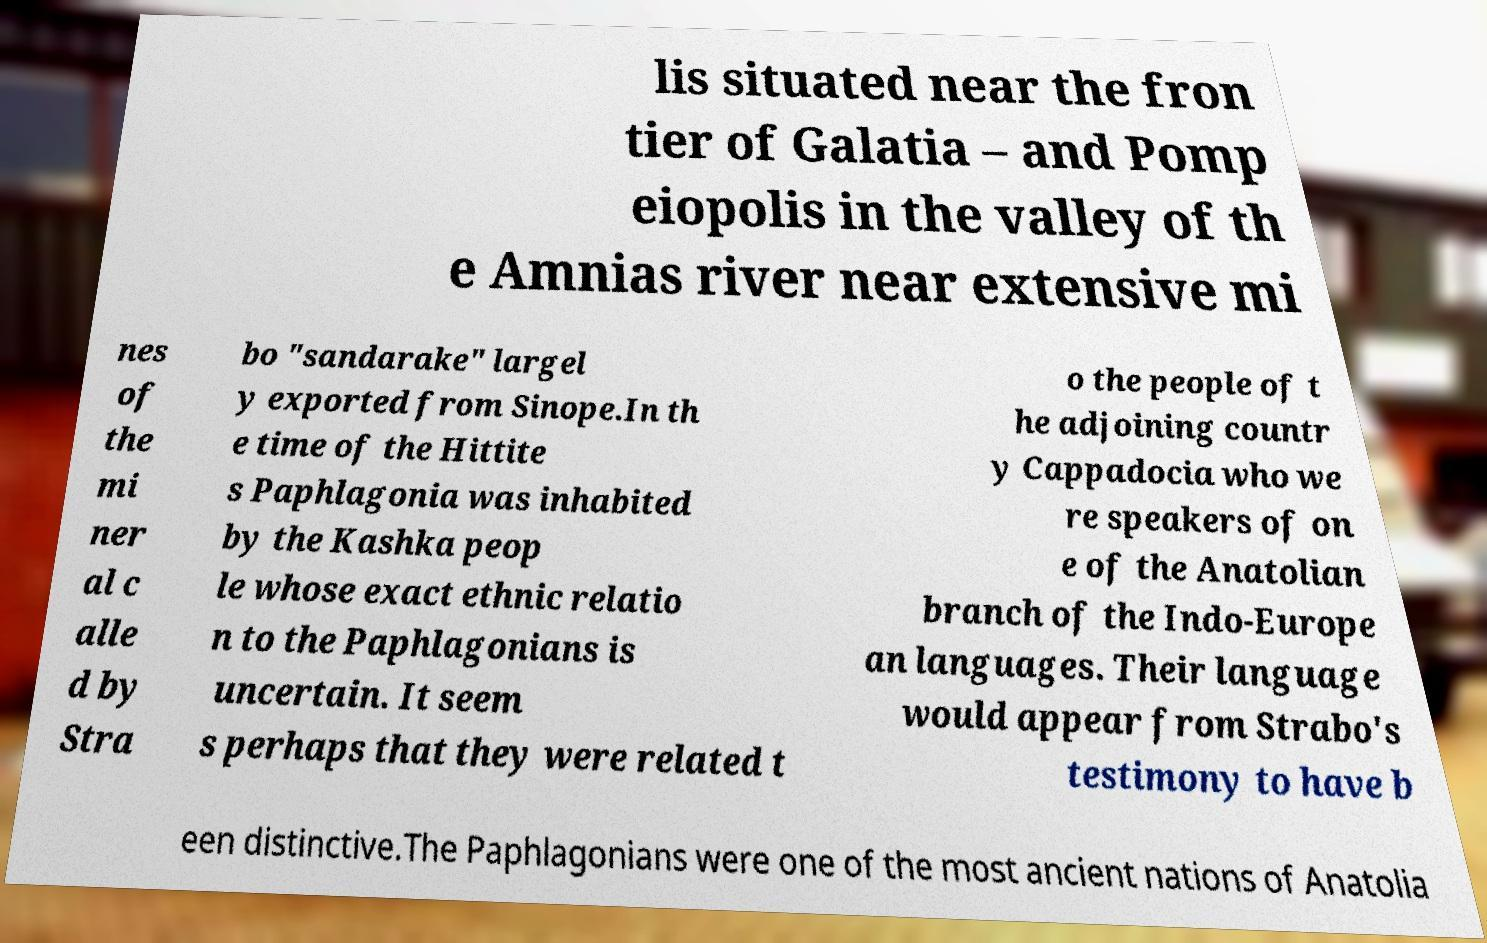Can you read and provide the text displayed in the image?This photo seems to have some interesting text. Can you extract and type it out for me? lis situated near the fron tier of Galatia – and Pomp eiopolis in the valley of th e Amnias river near extensive mi nes of the mi ner al c alle d by Stra bo "sandarake" largel y exported from Sinope.In th e time of the Hittite s Paphlagonia was inhabited by the Kashka peop le whose exact ethnic relatio n to the Paphlagonians is uncertain. It seem s perhaps that they were related t o the people of t he adjoining countr y Cappadocia who we re speakers of on e of the Anatolian branch of the Indo-Europe an languages. Their language would appear from Strabo's testimony to have b een distinctive.The Paphlagonians were one of the most ancient nations of Anatolia 